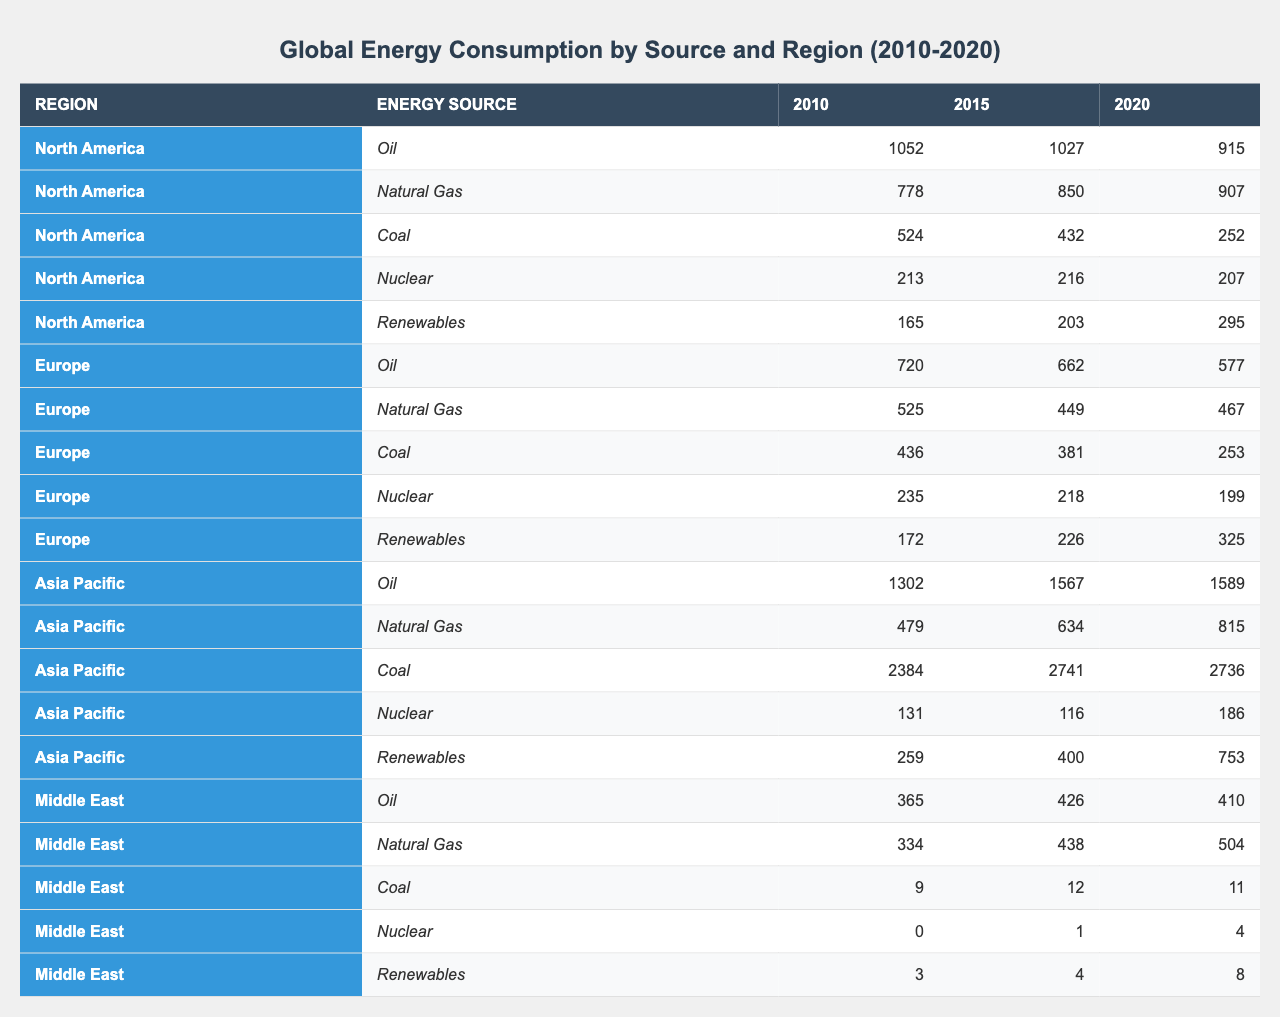What was the oil consumption in North America in 2020? Referring to the table, the oil consumption in North America for 2020 was 915 Mtoe.
Answer: 915 Mtoe Which region showed the highest consumption of coal in 2010? The table indicates that in 2010, Asia Pacific had the highest coal consumption at 2384 Mtoe compared to other regions.
Answer: Asia Pacific What is the total natural gas consumption in Europe from 2010 to 2020? Adding the natural gas consumption values from 2010 (525 Mtoe), 2015 (449 Mtoe), and 2020 (467 Mtoe) gives 525 + 449 + 467 = 1441 Mtoe.
Answer: 1441 Mtoe Did the consumption of coal in Europe decrease from 2010 to 2020? The table shows that coal consumption in Europe decreased from 436 Mtoe in 2010 to 253 Mtoe in 2020, indicating a decline.
Answer: Yes How much has the consumption of renewables increased in Asia Pacific from 2010 to 2020? The difference in renewable consumption from 2010 (259 Mtoe) to 2020 (753 Mtoe) is calculated as 753 - 259 = 494 Mtoe increase.
Answer: 494 Mtoe Was the nuclear consumption in the Middle East higher in 2020 than in 2015? Comparing the table figures, nuclear consumption in 2015 was 1 Mtoe and in 2020 it was 4 Mtoe; thus, it increased.
Answer: Yes What is the average oil consumption for North America over the years 2010, 2015, and 2020? Summing the oil consumption values of 2010 (1052 Mtoe), 2015 (1027 Mtoe), and 2020 (915 Mtoe) gives 1052 + 1027 + 915 = 2994 Mtoe. Dividing by 3 yields an average of 2994 / 3 = 998 Mtoe.
Answer: 998 Mtoe Which region had the least coal consumption in 2020? In 2020, the data shows that the Middle East had the least coal consumption at 11 Mtoe, lower than any other region.
Answer: Middle East What was the change in natural gas consumption in North America from 2010 to 2020? The natural gas consumption changed from 778 Mtoe in 2010 to 907 Mtoe in 2020, which is an increase of 907 - 778 = 129 Mtoe.
Answer: 129 Mtoe In which year did Europe and North America have the same oil consumption? By comparing the table, in 2015, Europe had 662 Mtoe and North America had 1027 Mtoe, thus they never matched. No year matched their oil consumption.
Answer: No year matched 